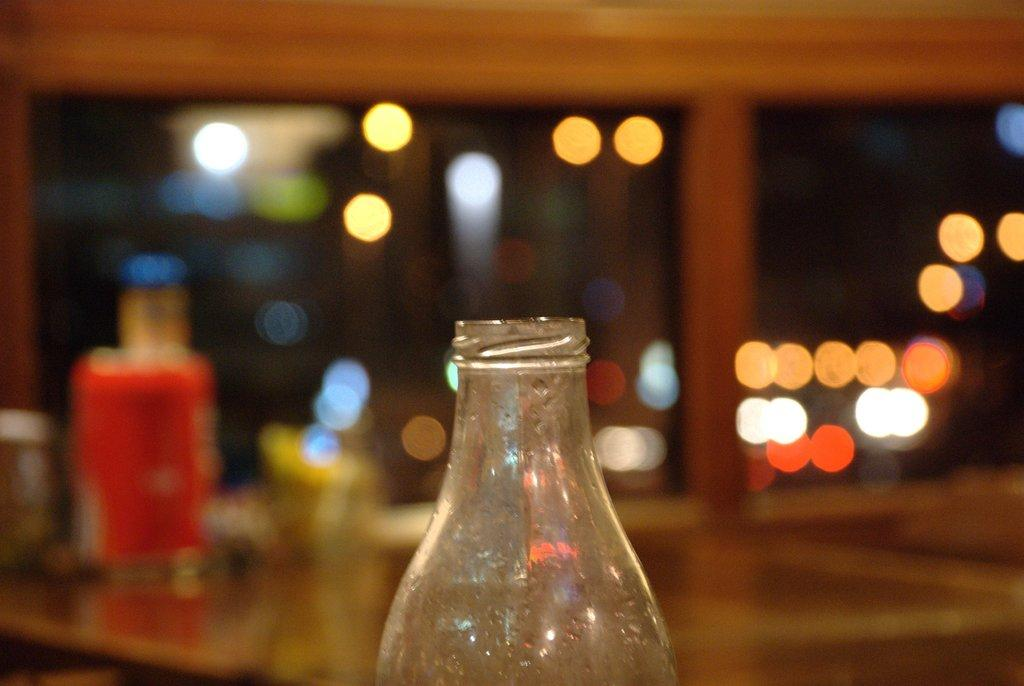What is the main object in the middle of the image? There is a bottle in the middle of the image. Can you describe the background of the image? The background of the image is blurred. What type of chain can be seen hanging from the bottle in the image? There is no chain present in the image; it only features a bottle. What school-related activity is happening in the image? There is no school-related activity depicted in the image, as it only features a bottle and a blurred background. 